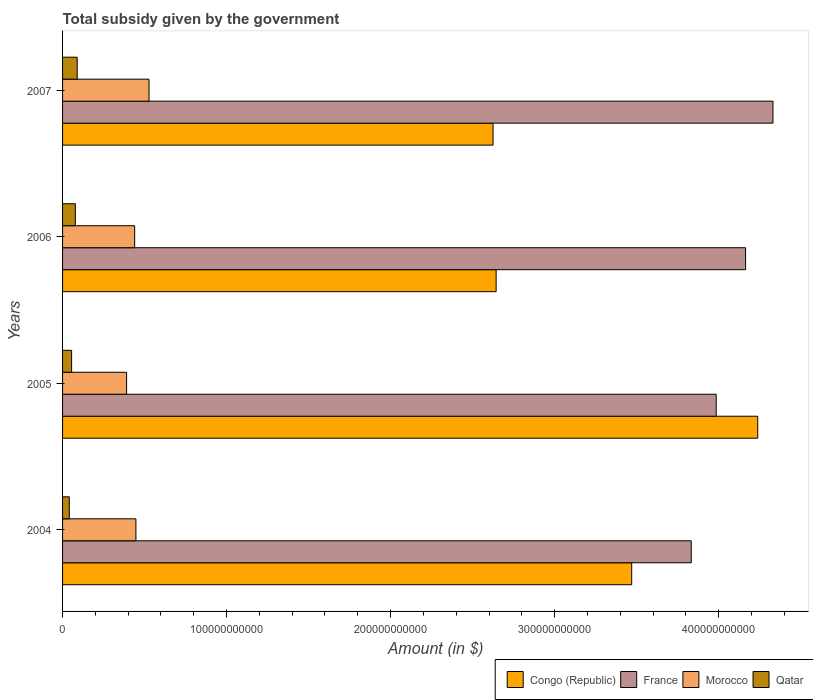Are the number of bars on each tick of the Y-axis equal?
Your answer should be very brief. Yes. What is the label of the 3rd group of bars from the top?
Your answer should be very brief. 2005. What is the total revenue collected by the government in France in 2004?
Your answer should be compact. 3.83e+11. Across all years, what is the maximum total revenue collected by the government in Morocco?
Offer a terse response. 5.27e+1. Across all years, what is the minimum total revenue collected by the government in Morocco?
Your answer should be compact. 3.90e+1. In which year was the total revenue collected by the government in Qatar maximum?
Make the answer very short. 2007. In which year was the total revenue collected by the government in Qatar minimum?
Ensure brevity in your answer.  2004. What is the total total revenue collected by the government in Morocco in the graph?
Provide a short and direct response. 1.80e+11. What is the difference between the total revenue collected by the government in Morocco in 2005 and that in 2007?
Offer a very short reply. -1.37e+1. What is the difference between the total revenue collected by the government in France in 2006 and the total revenue collected by the government in Qatar in 2007?
Keep it short and to the point. 4.08e+11. What is the average total revenue collected by the government in Congo (Republic) per year?
Provide a succinct answer. 3.24e+11. In the year 2005, what is the difference between the total revenue collected by the government in Morocco and total revenue collected by the government in Congo (Republic)?
Make the answer very short. -3.85e+11. What is the ratio of the total revenue collected by the government in Qatar in 2005 to that in 2007?
Your answer should be compact. 0.62. What is the difference between the highest and the second highest total revenue collected by the government in France?
Ensure brevity in your answer.  1.67e+1. What is the difference between the highest and the lowest total revenue collected by the government in Congo (Republic)?
Provide a succinct answer. 1.61e+11. In how many years, is the total revenue collected by the government in Qatar greater than the average total revenue collected by the government in Qatar taken over all years?
Your answer should be very brief. 2. Is the sum of the total revenue collected by the government in France in 2005 and 2006 greater than the maximum total revenue collected by the government in Qatar across all years?
Make the answer very short. Yes. What does the 4th bar from the bottom in 2007 represents?
Provide a succinct answer. Qatar. Is it the case that in every year, the sum of the total revenue collected by the government in France and total revenue collected by the government in Morocco is greater than the total revenue collected by the government in Congo (Republic)?
Keep it short and to the point. Yes. How many bars are there?
Offer a very short reply. 16. How many years are there in the graph?
Your answer should be very brief. 4. What is the difference between two consecutive major ticks on the X-axis?
Your response must be concise. 1.00e+11. How many legend labels are there?
Your response must be concise. 4. What is the title of the graph?
Offer a terse response. Total subsidy given by the government. Does "Switzerland" appear as one of the legend labels in the graph?
Make the answer very short. No. What is the label or title of the X-axis?
Ensure brevity in your answer.  Amount (in $). What is the Amount (in $) in Congo (Republic) in 2004?
Your answer should be compact. 3.47e+11. What is the Amount (in $) in France in 2004?
Make the answer very short. 3.83e+11. What is the Amount (in $) in Morocco in 2004?
Keep it short and to the point. 4.47e+1. What is the Amount (in $) in Qatar in 2004?
Offer a terse response. 4.11e+09. What is the Amount (in $) of Congo (Republic) in 2005?
Offer a very short reply. 4.24e+11. What is the Amount (in $) in France in 2005?
Give a very brief answer. 3.99e+11. What is the Amount (in $) in Morocco in 2005?
Give a very brief answer. 3.90e+1. What is the Amount (in $) of Qatar in 2005?
Make the answer very short. 5.51e+09. What is the Amount (in $) of Congo (Republic) in 2006?
Provide a short and direct response. 2.64e+11. What is the Amount (in $) of France in 2006?
Offer a terse response. 4.16e+11. What is the Amount (in $) of Morocco in 2006?
Your response must be concise. 4.40e+1. What is the Amount (in $) of Qatar in 2006?
Your response must be concise. 7.79e+09. What is the Amount (in $) of Congo (Republic) in 2007?
Ensure brevity in your answer.  2.62e+11. What is the Amount (in $) of France in 2007?
Make the answer very short. 4.33e+11. What is the Amount (in $) of Morocco in 2007?
Offer a very short reply. 5.27e+1. What is the Amount (in $) of Qatar in 2007?
Provide a short and direct response. 8.92e+09. Across all years, what is the maximum Amount (in $) of Congo (Republic)?
Offer a terse response. 4.24e+11. Across all years, what is the maximum Amount (in $) in France?
Ensure brevity in your answer.  4.33e+11. Across all years, what is the maximum Amount (in $) in Morocco?
Offer a very short reply. 5.27e+1. Across all years, what is the maximum Amount (in $) in Qatar?
Make the answer very short. 8.92e+09. Across all years, what is the minimum Amount (in $) in Congo (Republic)?
Give a very brief answer. 2.62e+11. Across all years, what is the minimum Amount (in $) of France?
Give a very brief answer. 3.83e+11. Across all years, what is the minimum Amount (in $) of Morocco?
Your answer should be compact. 3.90e+1. Across all years, what is the minimum Amount (in $) of Qatar?
Ensure brevity in your answer.  4.11e+09. What is the total Amount (in $) of Congo (Republic) in the graph?
Give a very brief answer. 1.30e+12. What is the total Amount (in $) in France in the graph?
Offer a very short reply. 1.63e+12. What is the total Amount (in $) in Morocco in the graph?
Your response must be concise. 1.80e+11. What is the total Amount (in $) in Qatar in the graph?
Provide a succinct answer. 2.63e+1. What is the difference between the Amount (in $) in Congo (Republic) in 2004 and that in 2005?
Offer a terse response. -7.68e+1. What is the difference between the Amount (in $) of France in 2004 and that in 2005?
Your answer should be very brief. -1.52e+1. What is the difference between the Amount (in $) in Morocco in 2004 and that in 2005?
Keep it short and to the point. 5.68e+09. What is the difference between the Amount (in $) in Qatar in 2004 and that in 2005?
Provide a succinct answer. -1.41e+09. What is the difference between the Amount (in $) of Congo (Republic) in 2004 and that in 2006?
Give a very brief answer. 8.27e+1. What is the difference between the Amount (in $) of France in 2004 and that in 2006?
Keep it short and to the point. -3.31e+1. What is the difference between the Amount (in $) of Morocco in 2004 and that in 2006?
Ensure brevity in your answer.  7.60e+08. What is the difference between the Amount (in $) in Qatar in 2004 and that in 2006?
Your answer should be compact. -3.68e+09. What is the difference between the Amount (in $) of Congo (Republic) in 2004 and that in 2007?
Your response must be concise. 8.45e+1. What is the difference between the Amount (in $) in France in 2004 and that in 2007?
Ensure brevity in your answer.  -4.98e+1. What is the difference between the Amount (in $) in Morocco in 2004 and that in 2007?
Ensure brevity in your answer.  -7.99e+09. What is the difference between the Amount (in $) of Qatar in 2004 and that in 2007?
Offer a terse response. -4.81e+09. What is the difference between the Amount (in $) in Congo (Republic) in 2005 and that in 2006?
Your response must be concise. 1.60e+11. What is the difference between the Amount (in $) in France in 2005 and that in 2006?
Make the answer very short. -1.79e+1. What is the difference between the Amount (in $) of Morocco in 2005 and that in 2006?
Your response must be concise. -4.92e+09. What is the difference between the Amount (in $) in Qatar in 2005 and that in 2006?
Offer a terse response. -2.28e+09. What is the difference between the Amount (in $) in Congo (Republic) in 2005 and that in 2007?
Make the answer very short. 1.61e+11. What is the difference between the Amount (in $) of France in 2005 and that in 2007?
Offer a terse response. -3.46e+1. What is the difference between the Amount (in $) of Morocco in 2005 and that in 2007?
Provide a short and direct response. -1.37e+1. What is the difference between the Amount (in $) in Qatar in 2005 and that in 2007?
Make the answer very short. -3.41e+09. What is the difference between the Amount (in $) in Congo (Republic) in 2006 and that in 2007?
Your response must be concise. 1.88e+09. What is the difference between the Amount (in $) of France in 2006 and that in 2007?
Offer a terse response. -1.67e+1. What is the difference between the Amount (in $) of Morocco in 2006 and that in 2007?
Offer a terse response. -8.75e+09. What is the difference between the Amount (in $) in Qatar in 2006 and that in 2007?
Your response must be concise. -1.13e+09. What is the difference between the Amount (in $) in Congo (Republic) in 2004 and the Amount (in $) in France in 2005?
Your answer should be very brief. -5.15e+1. What is the difference between the Amount (in $) of Congo (Republic) in 2004 and the Amount (in $) of Morocco in 2005?
Give a very brief answer. 3.08e+11. What is the difference between the Amount (in $) in Congo (Republic) in 2004 and the Amount (in $) in Qatar in 2005?
Offer a terse response. 3.41e+11. What is the difference between the Amount (in $) in France in 2004 and the Amount (in $) in Morocco in 2005?
Give a very brief answer. 3.44e+11. What is the difference between the Amount (in $) of France in 2004 and the Amount (in $) of Qatar in 2005?
Your answer should be very brief. 3.78e+11. What is the difference between the Amount (in $) of Morocco in 2004 and the Amount (in $) of Qatar in 2005?
Offer a very short reply. 3.92e+1. What is the difference between the Amount (in $) of Congo (Republic) in 2004 and the Amount (in $) of France in 2006?
Give a very brief answer. -6.94e+1. What is the difference between the Amount (in $) in Congo (Republic) in 2004 and the Amount (in $) in Morocco in 2006?
Keep it short and to the point. 3.03e+11. What is the difference between the Amount (in $) of Congo (Republic) in 2004 and the Amount (in $) of Qatar in 2006?
Provide a short and direct response. 3.39e+11. What is the difference between the Amount (in $) of France in 2004 and the Amount (in $) of Morocco in 2006?
Your response must be concise. 3.39e+11. What is the difference between the Amount (in $) of France in 2004 and the Amount (in $) of Qatar in 2006?
Your answer should be compact. 3.76e+11. What is the difference between the Amount (in $) of Morocco in 2004 and the Amount (in $) of Qatar in 2006?
Make the answer very short. 3.69e+1. What is the difference between the Amount (in $) in Congo (Republic) in 2004 and the Amount (in $) in France in 2007?
Your answer should be very brief. -8.61e+1. What is the difference between the Amount (in $) of Congo (Republic) in 2004 and the Amount (in $) of Morocco in 2007?
Keep it short and to the point. 2.94e+11. What is the difference between the Amount (in $) of Congo (Republic) in 2004 and the Amount (in $) of Qatar in 2007?
Your answer should be compact. 3.38e+11. What is the difference between the Amount (in $) in France in 2004 and the Amount (in $) in Morocco in 2007?
Your answer should be very brief. 3.31e+11. What is the difference between the Amount (in $) in France in 2004 and the Amount (in $) in Qatar in 2007?
Provide a short and direct response. 3.74e+11. What is the difference between the Amount (in $) of Morocco in 2004 and the Amount (in $) of Qatar in 2007?
Provide a succinct answer. 3.58e+1. What is the difference between the Amount (in $) of Congo (Republic) in 2005 and the Amount (in $) of France in 2006?
Your answer should be very brief. 7.41e+09. What is the difference between the Amount (in $) of Congo (Republic) in 2005 and the Amount (in $) of Morocco in 2006?
Offer a terse response. 3.80e+11. What is the difference between the Amount (in $) of Congo (Republic) in 2005 and the Amount (in $) of Qatar in 2006?
Your answer should be very brief. 4.16e+11. What is the difference between the Amount (in $) in France in 2005 and the Amount (in $) in Morocco in 2006?
Keep it short and to the point. 3.55e+11. What is the difference between the Amount (in $) in France in 2005 and the Amount (in $) in Qatar in 2006?
Provide a short and direct response. 3.91e+11. What is the difference between the Amount (in $) in Morocco in 2005 and the Amount (in $) in Qatar in 2006?
Your answer should be compact. 3.13e+1. What is the difference between the Amount (in $) in Congo (Republic) in 2005 and the Amount (in $) in France in 2007?
Offer a terse response. -9.29e+09. What is the difference between the Amount (in $) of Congo (Republic) in 2005 and the Amount (in $) of Morocco in 2007?
Ensure brevity in your answer.  3.71e+11. What is the difference between the Amount (in $) in Congo (Republic) in 2005 and the Amount (in $) in Qatar in 2007?
Offer a terse response. 4.15e+11. What is the difference between the Amount (in $) of France in 2005 and the Amount (in $) of Morocco in 2007?
Offer a very short reply. 3.46e+11. What is the difference between the Amount (in $) in France in 2005 and the Amount (in $) in Qatar in 2007?
Your answer should be very brief. 3.90e+11. What is the difference between the Amount (in $) of Morocco in 2005 and the Amount (in $) of Qatar in 2007?
Provide a succinct answer. 3.01e+1. What is the difference between the Amount (in $) of Congo (Republic) in 2006 and the Amount (in $) of France in 2007?
Your response must be concise. -1.69e+11. What is the difference between the Amount (in $) of Congo (Republic) in 2006 and the Amount (in $) of Morocco in 2007?
Provide a succinct answer. 2.12e+11. What is the difference between the Amount (in $) in Congo (Republic) in 2006 and the Amount (in $) in Qatar in 2007?
Your response must be concise. 2.55e+11. What is the difference between the Amount (in $) in France in 2006 and the Amount (in $) in Morocco in 2007?
Your answer should be very brief. 3.64e+11. What is the difference between the Amount (in $) in France in 2006 and the Amount (in $) in Qatar in 2007?
Provide a succinct answer. 4.08e+11. What is the difference between the Amount (in $) in Morocco in 2006 and the Amount (in $) in Qatar in 2007?
Provide a short and direct response. 3.50e+1. What is the average Amount (in $) of Congo (Republic) per year?
Offer a very short reply. 3.24e+11. What is the average Amount (in $) of France per year?
Offer a terse response. 4.08e+11. What is the average Amount (in $) in Morocco per year?
Make the answer very short. 4.51e+1. What is the average Amount (in $) of Qatar per year?
Make the answer very short. 6.58e+09. In the year 2004, what is the difference between the Amount (in $) of Congo (Republic) and Amount (in $) of France?
Your answer should be very brief. -3.63e+1. In the year 2004, what is the difference between the Amount (in $) in Congo (Republic) and Amount (in $) in Morocco?
Offer a very short reply. 3.02e+11. In the year 2004, what is the difference between the Amount (in $) of Congo (Republic) and Amount (in $) of Qatar?
Your answer should be very brief. 3.43e+11. In the year 2004, what is the difference between the Amount (in $) of France and Amount (in $) of Morocco?
Your answer should be compact. 3.39e+11. In the year 2004, what is the difference between the Amount (in $) in France and Amount (in $) in Qatar?
Keep it short and to the point. 3.79e+11. In the year 2004, what is the difference between the Amount (in $) in Morocco and Amount (in $) in Qatar?
Make the answer very short. 4.06e+1. In the year 2005, what is the difference between the Amount (in $) of Congo (Republic) and Amount (in $) of France?
Provide a short and direct response. 2.53e+1. In the year 2005, what is the difference between the Amount (in $) of Congo (Republic) and Amount (in $) of Morocco?
Your response must be concise. 3.85e+11. In the year 2005, what is the difference between the Amount (in $) of Congo (Republic) and Amount (in $) of Qatar?
Your answer should be very brief. 4.18e+11. In the year 2005, what is the difference between the Amount (in $) of France and Amount (in $) of Morocco?
Provide a short and direct response. 3.59e+11. In the year 2005, what is the difference between the Amount (in $) of France and Amount (in $) of Qatar?
Keep it short and to the point. 3.93e+11. In the year 2005, what is the difference between the Amount (in $) of Morocco and Amount (in $) of Qatar?
Offer a terse response. 3.35e+1. In the year 2006, what is the difference between the Amount (in $) of Congo (Republic) and Amount (in $) of France?
Provide a short and direct response. -1.52e+11. In the year 2006, what is the difference between the Amount (in $) of Congo (Republic) and Amount (in $) of Morocco?
Ensure brevity in your answer.  2.20e+11. In the year 2006, what is the difference between the Amount (in $) in Congo (Republic) and Amount (in $) in Qatar?
Offer a terse response. 2.57e+11. In the year 2006, what is the difference between the Amount (in $) of France and Amount (in $) of Morocco?
Give a very brief answer. 3.72e+11. In the year 2006, what is the difference between the Amount (in $) in France and Amount (in $) in Qatar?
Give a very brief answer. 4.09e+11. In the year 2006, what is the difference between the Amount (in $) of Morocco and Amount (in $) of Qatar?
Your response must be concise. 3.62e+1. In the year 2007, what is the difference between the Amount (in $) of Congo (Republic) and Amount (in $) of France?
Give a very brief answer. -1.71e+11. In the year 2007, what is the difference between the Amount (in $) in Congo (Republic) and Amount (in $) in Morocco?
Provide a short and direct response. 2.10e+11. In the year 2007, what is the difference between the Amount (in $) of Congo (Republic) and Amount (in $) of Qatar?
Provide a succinct answer. 2.54e+11. In the year 2007, what is the difference between the Amount (in $) in France and Amount (in $) in Morocco?
Make the answer very short. 3.80e+11. In the year 2007, what is the difference between the Amount (in $) of France and Amount (in $) of Qatar?
Make the answer very short. 4.24e+11. In the year 2007, what is the difference between the Amount (in $) of Morocco and Amount (in $) of Qatar?
Keep it short and to the point. 4.38e+1. What is the ratio of the Amount (in $) in Congo (Republic) in 2004 to that in 2005?
Your answer should be very brief. 0.82. What is the ratio of the Amount (in $) in France in 2004 to that in 2005?
Your answer should be very brief. 0.96. What is the ratio of the Amount (in $) in Morocco in 2004 to that in 2005?
Your response must be concise. 1.15. What is the ratio of the Amount (in $) of Qatar in 2004 to that in 2005?
Make the answer very short. 0.74. What is the ratio of the Amount (in $) in Congo (Republic) in 2004 to that in 2006?
Give a very brief answer. 1.31. What is the ratio of the Amount (in $) in France in 2004 to that in 2006?
Offer a terse response. 0.92. What is the ratio of the Amount (in $) of Morocco in 2004 to that in 2006?
Keep it short and to the point. 1.02. What is the ratio of the Amount (in $) of Qatar in 2004 to that in 2006?
Offer a very short reply. 0.53. What is the ratio of the Amount (in $) in Congo (Republic) in 2004 to that in 2007?
Make the answer very short. 1.32. What is the ratio of the Amount (in $) in France in 2004 to that in 2007?
Offer a very short reply. 0.89. What is the ratio of the Amount (in $) of Morocco in 2004 to that in 2007?
Your answer should be compact. 0.85. What is the ratio of the Amount (in $) of Qatar in 2004 to that in 2007?
Provide a short and direct response. 0.46. What is the ratio of the Amount (in $) of Congo (Republic) in 2005 to that in 2006?
Offer a terse response. 1.6. What is the ratio of the Amount (in $) in France in 2005 to that in 2006?
Ensure brevity in your answer.  0.96. What is the ratio of the Amount (in $) in Morocco in 2005 to that in 2006?
Give a very brief answer. 0.89. What is the ratio of the Amount (in $) of Qatar in 2005 to that in 2006?
Your response must be concise. 0.71. What is the ratio of the Amount (in $) in Congo (Republic) in 2005 to that in 2007?
Provide a short and direct response. 1.61. What is the ratio of the Amount (in $) in France in 2005 to that in 2007?
Give a very brief answer. 0.92. What is the ratio of the Amount (in $) in Morocco in 2005 to that in 2007?
Ensure brevity in your answer.  0.74. What is the ratio of the Amount (in $) of Qatar in 2005 to that in 2007?
Offer a very short reply. 0.62. What is the ratio of the Amount (in $) in France in 2006 to that in 2007?
Make the answer very short. 0.96. What is the ratio of the Amount (in $) in Morocco in 2006 to that in 2007?
Your response must be concise. 0.83. What is the ratio of the Amount (in $) in Qatar in 2006 to that in 2007?
Your answer should be very brief. 0.87. What is the difference between the highest and the second highest Amount (in $) in Congo (Republic)?
Your answer should be compact. 7.68e+1. What is the difference between the highest and the second highest Amount (in $) in France?
Provide a succinct answer. 1.67e+1. What is the difference between the highest and the second highest Amount (in $) in Morocco?
Give a very brief answer. 7.99e+09. What is the difference between the highest and the second highest Amount (in $) of Qatar?
Keep it short and to the point. 1.13e+09. What is the difference between the highest and the lowest Amount (in $) of Congo (Republic)?
Make the answer very short. 1.61e+11. What is the difference between the highest and the lowest Amount (in $) in France?
Provide a short and direct response. 4.98e+1. What is the difference between the highest and the lowest Amount (in $) in Morocco?
Your response must be concise. 1.37e+1. What is the difference between the highest and the lowest Amount (in $) in Qatar?
Provide a short and direct response. 4.81e+09. 